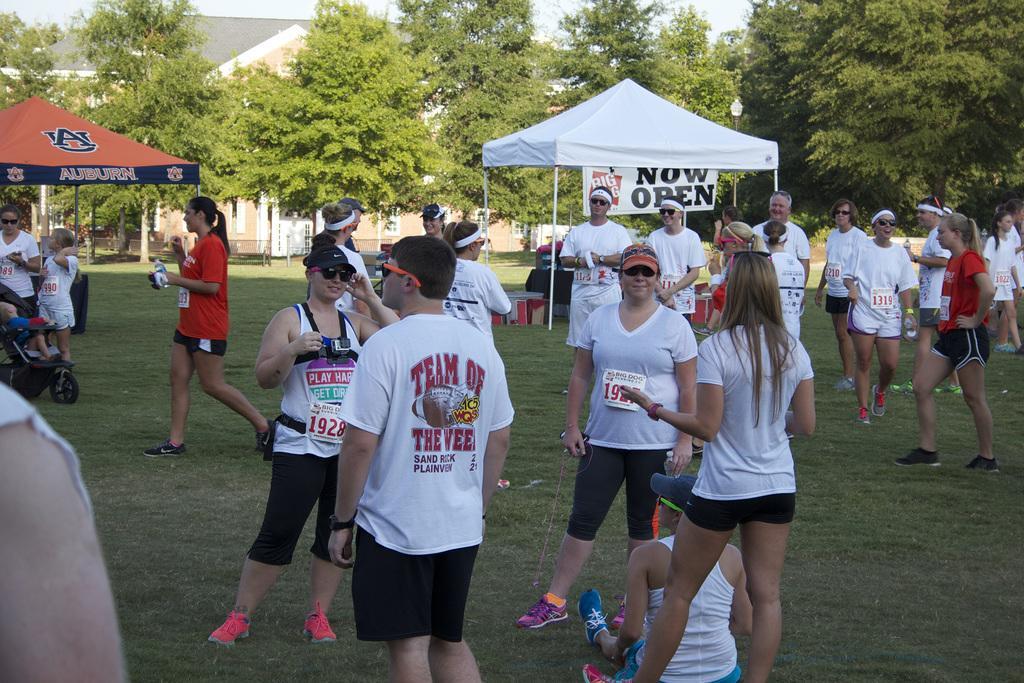Describe this image in one or two sentences. In the image there are many people standing on the ground in the foreground, behind them there are two tents and in the background there are trees, behind the trees there is a house. 